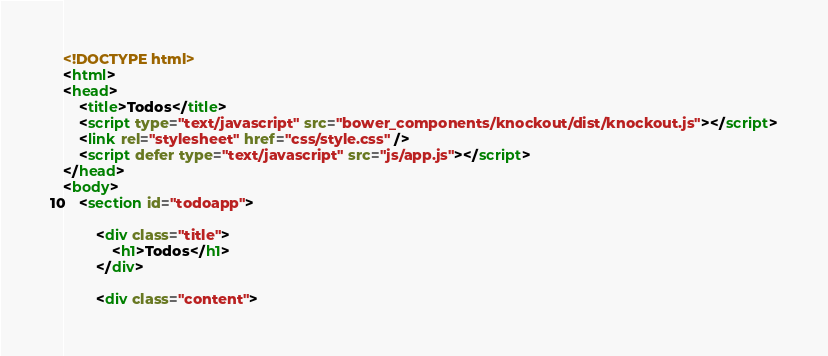Convert code to text. <code><loc_0><loc_0><loc_500><loc_500><_HTML_><!DOCTYPE html>
<html>
<head>
	<title>Todos</title>
	<script type="text/javascript" src="bower_components/knockout/dist/knockout.js"></script>
	<link rel="stylesheet" href="css/style.css" />
	<script defer type="text/javascript" src="js/app.js"></script>
</head>
<body>
	<section id="todoapp">

	    <div class="title">
	        <h1>Todos</h1>
	    </div>

	    <div class="content"></code> 